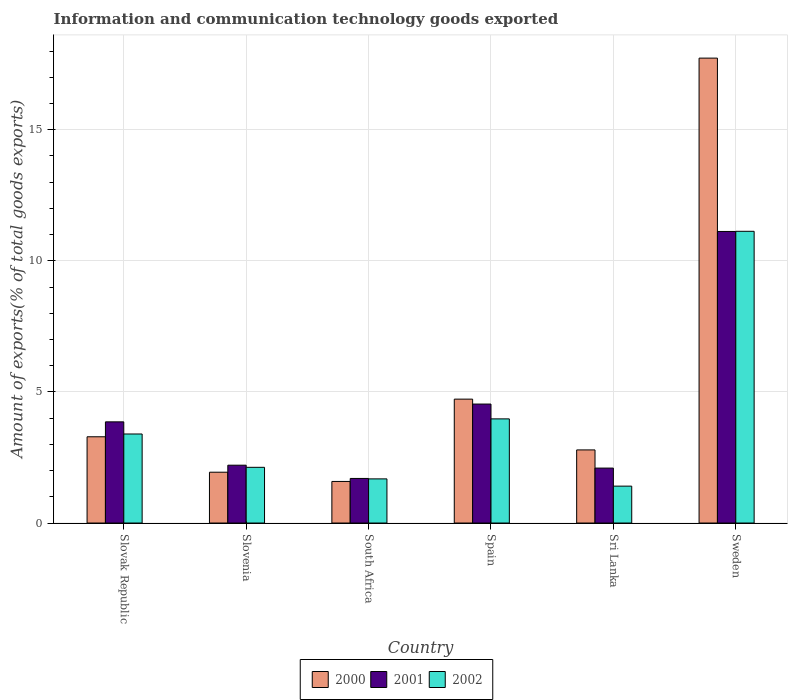How many different coloured bars are there?
Provide a short and direct response. 3. How many groups of bars are there?
Offer a terse response. 6. How many bars are there on the 2nd tick from the left?
Make the answer very short. 3. How many bars are there on the 5th tick from the right?
Keep it short and to the point. 3. What is the label of the 2nd group of bars from the left?
Offer a terse response. Slovenia. In how many cases, is the number of bars for a given country not equal to the number of legend labels?
Your answer should be very brief. 0. What is the amount of goods exported in 2001 in Spain?
Provide a short and direct response. 4.54. Across all countries, what is the maximum amount of goods exported in 2001?
Keep it short and to the point. 11.12. Across all countries, what is the minimum amount of goods exported in 2000?
Your answer should be very brief. 1.59. In which country was the amount of goods exported in 2000 minimum?
Provide a succinct answer. South Africa. What is the total amount of goods exported in 2002 in the graph?
Give a very brief answer. 23.71. What is the difference between the amount of goods exported in 2001 in South Africa and that in Sweden?
Offer a terse response. -9.42. What is the difference between the amount of goods exported in 2000 in Sri Lanka and the amount of goods exported in 2002 in Sweden?
Keep it short and to the point. -8.34. What is the average amount of goods exported in 2002 per country?
Your response must be concise. 3.95. What is the difference between the amount of goods exported of/in 2002 and amount of goods exported of/in 2001 in Slovak Republic?
Give a very brief answer. -0.46. What is the ratio of the amount of goods exported in 2000 in South Africa to that in Sri Lanka?
Ensure brevity in your answer.  0.57. Is the difference between the amount of goods exported in 2002 in Spain and Sweden greater than the difference between the amount of goods exported in 2001 in Spain and Sweden?
Ensure brevity in your answer.  No. What is the difference between the highest and the second highest amount of goods exported in 2000?
Your answer should be compact. 14.44. What is the difference between the highest and the lowest amount of goods exported in 2002?
Give a very brief answer. 9.72. In how many countries, is the amount of goods exported in 2001 greater than the average amount of goods exported in 2001 taken over all countries?
Offer a very short reply. 2. Is it the case that in every country, the sum of the amount of goods exported in 2000 and amount of goods exported in 2001 is greater than the amount of goods exported in 2002?
Make the answer very short. Yes. How many legend labels are there?
Give a very brief answer. 3. What is the title of the graph?
Your response must be concise. Information and communication technology goods exported. What is the label or title of the X-axis?
Provide a succinct answer. Country. What is the label or title of the Y-axis?
Offer a very short reply. Amount of exports(% of total goods exports). What is the Amount of exports(% of total goods exports) in 2000 in Slovak Republic?
Provide a succinct answer. 3.29. What is the Amount of exports(% of total goods exports) of 2001 in Slovak Republic?
Make the answer very short. 3.86. What is the Amount of exports(% of total goods exports) of 2002 in Slovak Republic?
Provide a short and direct response. 3.4. What is the Amount of exports(% of total goods exports) in 2000 in Slovenia?
Your answer should be compact. 1.94. What is the Amount of exports(% of total goods exports) of 2001 in Slovenia?
Your answer should be very brief. 2.21. What is the Amount of exports(% of total goods exports) of 2002 in Slovenia?
Ensure brevity in your answer.  2.12. What is the Amount of exports(% of total goods exports) in 2000 in South Africa?
Keep it short and to the point. 1.59. What is the Amount of exports(% of total goods exports) of 2001 in South Africa?
Offer a terse response. 1.7. What is the Amount of exports(% of total goods exports) in 2002 in South Africa?
Offer a terse response. 1.68. What is the Amount of exports(% of total goods exports) in 2000 in Spain?
Provide a succinct answer. 4.72. What is the Amount of exports(% of total goods exports) in 2001 in Spain?
Give a very brief answer. 4.54. What is the Amount of exports(% of total goods exports) in 2002 in Spain?
Your answer should be compact. 3.97. What is the Amount of exports(% of total goods exports) in 2000 in Sri Lanka?
Your response must be concise. 2.79. What is the Amount of exports(% of total goods exports) of 2001 in Sri Lanka?
Provide a short and direct response. 2.1. What is the Amount of exports(% of total goods exports) of 2002 in Sri Lanka?
Ensure brevity in your answer.  1.41. What is the Amount of exports(% of total goods exports) in 2000 in Sweden?
Your answer should be compact. 17.73. What is the Amount of exports(% of total goods exports) of 2001 in Sweden?
Provide a short and direct response. 11.12. What is the Amount of exports(% of total goods exports) of 2002 in Sweden?
Provide a succinct answer. 11.13. Across all countries, what is the maximum Amount of exports(% of total goods exports) in 2000?
Provide a succinct answer. 17.73. Across all countries, what is the maximum Amount of exports(% of total goods exports) of 2001?
Provide a succinct answer. 11.12. Across all countries, what is the maximum Amount of exports(% of total goods exports) of 2002?
Provide a succinct answer. 11.13. Across all countries, what is the minimum Amount of exports(% of total goods exports) of 2000?
Your response must be concise. 1.59. Across all countries, what is the minimum Amount of exports(% of total goods exports) of 2001?
Ensure brevity in your answer.  1.7. Across all countries, what is the minimum Amount of exports(% of total goods exports) of 2002?
Make the answer very short. 1.41. What is the total Amount of exports(% of total goods exports) of 2000 in the graph?
Your answer should be compact. 32.06. What is the total Amount of exports(% of total goods exports) in 2001 in the graph?
Offer a very short reply. 25.52. What is the total Amount of exports(% of total goods exports) in 2002 in the graph?
Your answer should be very brief. 23.71. What is the difference between the Amount of exports(% of total goods exports) of 2000 in Slovak Republic and that in Slovenia?
Offer a terse response. 1.35. What is the difference between the Amount of exports(% of total goods exports) of 2001 in Slovak Republic and that in Slovenia?
Give a very brief answer. 1.65. What is the difference between the Amount of exports(% of total goods exports) of 2002 in Slovak Republic and that in Slovenia?
Your answer should be compact. 1.27. What is the difference between the Amount of exports(% of total goods exports) in 2000 in Slovak Republic and that in South Africa?
Give a very brief answer. 1.7. What is the difference between the Amount of exports(% of total goods exports) of 2001 in Slovak Republic and that in South Africa?
Offer a very short reply. 2.16. What is the difference between the Amount of exports(% of total goods exports) of 2002 in Slovak Republic and that in South Africa?
Give a very brief answer. 1.71. What is the difference between the Amount of exports(% of total goods exports) in 2000 in Slovak Republic and that in Spain?
Your answer should be very brief. -1.44. What is the difference between the Amount of exports(% of total goods exports) of 2001 in Slovak Republic and that in Spain?
Offer a very short reply. -0.68. What is the difference between the Amount of exports(% of total goods exports) of 2002 in Slovak Republic and that in Spain?
Your response must be concise. -0.58. What is the difference between the Amount of exports(% of total goods exports) in 2000 in Slovak Republic and that in Sri Lanka?
Your response must be concise. 0.5. What is the difference between the Amount of exports(% of total goods exports) in 2001 in Slovak Republic and that in Sri Lanka?
Offer a very short reply. 1.76. What is the difference between the Amount of exports(% of total goods exports) in 2002 in Slovak Republic and that in Sri Lanka?
Keep it short and to the point. 1.99. What is the difference between the Amount of exports(% of total goods exports) of 2000 in Slovak Republic and that in Sweden?
Ensure brevity in your answer.  -14.44. What is the difference between the Amount of exports(% of total goods exports) of 2001 in Slovak Republic and that in Sweden?
Make the answer very short. -7.26. What is the difference between the Amount of exports(% of total goods exports) of 2002 in Slovak Republic and that in Sweden?
Offer a very short reply. -7.73. What is the difference between the Amount of exports(% of total goods exports) in 2000 in Slovenia and that in South Africa?
Your answer should be compact. 0.35. What is the difference between the Amount of exports(% of total goods exports) in 2001 in Slovenia and that in South Africa?
Your response must be concise. 0.51. What is the difference between the Amount of exports(% of total goods exports) in 2002 in Slovenia and that in South Africa?
Make the answer very short. 0.44. What is the difference between the Amount of exports(% of total goods exports) in 2000 in Slovenia and that in Spain?
Give a very brief answer. -2.79. What is the difference between the Amount of exports(% of total goods exports) of 2001 in Slovenia and that in Spain?
Make the answer very short. -2.33. What is the difference between the Amount of exports(% of total goods exports) of 2002 in Slovenia and that in Spain?
Offer a terse response. -1.85. What is the difference between the Amount of exports(% of total goods exports) in 2000 in Slovenia and that in Sri Lanka?
Offer a terse response. -0.85. What is the difference between the Amount of exports(% of total goods exports) of 2001 in Slovenia and that in Sri Lanka?
Make the answer very short. 0.11. What is the difference between the Amount of exports(% of total goods exports) of 2002 in Slovenia and that in Sri Lanka?
Make the answer very short. 0.72. What is the difference between the Amount of exports(% of total goods exports) of 2000 in Slovenia and that in Sweden?
Give a very brief answer. -15.79. What is the difference between the Amount of exports(% of total goods exports) in 2001 in Slovenia and that in Sweden?
Offer a very short reply. -8.91. What is the difference between the Amount of exports(% of total goods exports) in 2002 in Slovenia and that in Sweden?
Keep it short and to the point. -9. What is the difference between the Amount of exports(% of total goods exports) of 2000 in South Africa and that in Spain?
Offer a terse response. -3.14. What is the difference between the Amount of exports(% of total goods exports) in 2001 in South Africa and that in Spain?
Make the answer very short. -2.84. What is the difference between the Amount of exports(% of total goods exports) in 2002 in South Africa and that in Spain?
Your response must be concise. -2.29. What is the difference between the Amount of exports(% of total goods exports) of 2000 in South Africa and that in Sri Lanka?
Offer a terse response. -1.2. What is the difference between the Amount of exports(% of total goods exports) in 2001 in South Africa and that in Sri Lanka?
Your answer should be very brief. -0.4. What is the difference between the Amount of exports(% of total goods exports) of 2002 in South Africa and that in Sri Lanka?
Offer a terse response. 0.28. What is the difference between the Amount of exports(% of total goods exports) in 2000 in South Africa and that in Sweden?
Make the answer very short. -16.14. What is the difference between the Amount of exports(% of total goods exports) of 2001 in South Africa and that in Sweden?
Offer a very short reply. -9.42. What is the difference between the Amount of exports(% of total goods exports) in 2002 in South Africa and that in Sweden?
Offer a very short reply. -9.44. What is the difference between the Amount of exports(% of total goods exports) of 2000 in Spain and that in Sri Lanka?
Offer a terse response. 1.94. What is the difference between the Amount of exports(% of total goods exports) of 2001 in Spain and that in Sri Lanka?
Provide a short and direct response. 2.44. What is the difference between the Amount of exports(% of total goods exports) in 2002 in Spain and that in Sri Lanka?
Your answer should be very brief. 2.56. What is the difference between the Amount of exports(% of total goods exports) in 2000 in Spain and that in Sweden?
Give a very brief answer. -13. What is the difference between the Amount of exports(% of total goods exports) in 2001 in Spain and that in Sweden?
Offer a terse response. -6.58. What is the difference between the Amount of exports(% of total goods exports) of 2002 in Spain and that in Sweden?
Provide a short and direct response. -7.15. What is the difference between the Amount of exports(% of total goods exports) of 2000 in Sri Lanka and that in Sweden?
Your answer should be very brief. -14.94. What is the difference between the Amount of exports(% of total goods exports) of 2001 in Sri Lanka and that in Sweden?
Your response must be concise. -9.02. What is the difference between the Amount of exports(% of total goods exports) of 2002 in Sri Lanka and that in Sweden?
Provide a short and direct response. -9.72. What is the difference between the Amount of exports(% of total goods exports) in 2000 in Slovak Republic and the Amount of exports(% of total goods exports) in 2001 in Slovenia?
Your response must be concise. 1.08. What is the difference between the Amount of exports(% of total goods exports) of 2000 in Slovak Republic and the Amount of exports(% of total goods exports) of 2002 in Slovenia?
Provide a succinct answer. 1.16. What is the difference between the Amount of exports(% of total goods exports) of 2001 in Slovak Republic and the Amount of exports(% of total goods exports) of 2002 in Slovenia?
Provide a short and direct response. 1.73. What is the difference between the Amount of exports(% of total goods exports) of 2000 in Slovak Republic and the Amount of exports(% of total goods exports) of 2001 in South Africa?
Keep it short and to the point. 1.59. What is the difference between the Amount of exports(% of total goods exports) of 2000 in Slovak Republic and the Amount of exports(% of total goods exports) of 2002 in South Africa?
Your answer should be compact. 1.61. What is the difference between the Amount of exports(% of total goods exports) of 2001 in Slovak Republic and the Amount of exports(% of total goods exports) of 2002 in South Africa?
Provide a succinct answer. 2.18. What is the difference between the Amount of exports(% of total goods exports) in 2000 in Slovak Republic and the Amount of exports(% of total goods exports) in 2001 in Spain?
Keep it short and to the point. -1.25. What is the difference between the Amount of exports(% of total goods exports) of 2000 in Slovak Republic and the Amount of exports(% of total goods exports) of 2002 in Spain?
Your answer should be compact. -0.68. What is the difference between the Amount of exports(% of total goods exports) in 2001 in Slovak Republic and the Amount of exports(% of total goods exports) in 2002 in Spain?
Offer a very short reply. -0.11. What is the difference between the Amount of exports(% of total goods exports) of 2000 in Slovak Republic and the Amount of exports(% of total goods exports) of 2001 in Sri Lanka?
Your answer should be compact. 1.19. What is the difference between the Amount of exports(% of total goods exports) of 2000 in Slovak Republic and the Amount of exports(% of total goods exports) of 2002 in Sri Lanka?
Offer a very short reply. 1.88. What is the difference between the Amount of exports(% of total goods exports) of 2001 in Slovak Republic and the Amount of exports(% of total goods exports) of 2002 in Sri Lanka?
Ensure brevity in your answer.  2.45. What is the difference between the Amount of exports(% of total goods exports) of 2000 in Slovak Republic and the Amount of exports(% of total goods exports) of 2001 in Sweden?
Give a very brief answer. -7.83. What is the difference between the Amount of exports(% of total goods exports) of 2000 in Slovak Republic and the Amount of exports(% of total goods exports) of 2002 in Sweden?
Your response must be concise. -7.84. What is the difference between the Amount of exports(% of total goods exports) in 2001 in Slovak Republic and the Amount of exports(% of total goods exports) in 2002 in Sweden?
Your answer should be compact. -7.27. What is the difference between the Amount of exports(% of total goods exports) of 2000 in Slovenia and the Amount of exports(% of total goods exports) of 2001 in South Africa?
Offer a very short reply. 0.24. What is the difference between the Amount of exports(% of total goods exports) in 2000 in Slovenia and the Amount of exports(% of total goods exports) in 2002 in South Africa?
Provide a succinct answer. 0.25. What is the difference between the Amount of exports(% of total goods exports) in 2001 in Slovenia and the Amount of exports(% of total goods exports) in 2002 in South Africa?
Ensure brevity in your answer.  0.52. What is the difference between the Amount of exports(% of total goods exports) of 2000 in Slovenia and the Amount of exports(% of total goods exports) of 2001 in Spain?
Give a very brief answer. -2.6. What is the difference between the Amount of exports(% of total goods exports) in 2000 in Slovenia and the Amount of exports(% of total goods exports) in 2002 in Spain?
Your answer should be very brief. -2.03. What is the difference between the Amount of exports(% of total goods exports) in 2001 in Slovenia and the Amount of exports(% of total goods exports) in 2002 in Spain?
Offer a very short reply. -1.77. What is the difference between the Amount of exports(% of total goods exports) in 2000 in Slovenia and the Amount of exports(% of total goods exports) in 2001 in Sri Lanka?
Keep it short and to the point. -0.16. What is the difference between the Amount of exports(% of total goods exports) of 2000 in Slovenia and the Amount of exports(% of total goods exports) of 2002 in Sri Lanka?
Make the answer very short. 0.53. What is the difference between the Amount of exports(% of total goods exports) in 2001 in Slovenia and the Amount of exports(% of total goods exports) in 2002 in Sri Lanka?
Make the answer very short. 0.8. What is the difference between the Amount of exports(% of total goods exports) in 2000 in Slovenia and the Amount of exports(% of total goods exports) in 2001 in Sweden?
Your answer should be very brief. -9.18. What is the difference between the Amount of exports(% of total goods exports) in 2000 in Slovenia and the Amount of exports(% of total goods exports) in 2002 in Sweden?
Make the answer very short. -9.19. What is the difference between the Amount of exports(% of total goods exports) of 2001 in Slovenia and the Amount of exports(% of total goods exports) of 2002 in Sweden?
Your answer should be very brief. -8.92. What is the difference between the Amount of exports(% of total goods exports) in 2000 in South Africa and the Amount of exports(% of total goods exports) in 2001 in Spain?
Provide a succinct answer. -2.95. What is the difference between the Amount of exports(% of total goods exports) of 2000 in South Africa and the Amount of exports(% of total goods exports) of 2002 in Spain?
Your answer should be compact. -2.39. What is the difference between the Amount of exports(% of total goods exports) of 2001 in South Africa and the Amount of exports(% of total goods exports) of 2002 in Spain?
Ensure brevity in your answer.  -2.27. What is the difference between the Amount of exports(% of total goods exports) in 2000 in South Africa and the Amount of exports(% of total goods exports) in 2001 in Sri Lanka?
Your response must be concise. -0.51. What is the difference between the Amount of exports(% of total goods exports) of 2000 in South Africa and the Amount of exports(% of total goods exports) of 2002 in Sri Lanka?
Your answer should be compact. 0.18. What is the difference between the Amount of exports(% of total goods exports) of 2001 in South Africa and the Amount of exports(% of total goods exports) of 2002 in Sri Lanka?
Keep it short and to the point. 0.29. What is the difference between the Amount of exports(% of total goods exports) of 2000 in South Africa and the Amount of exports(% of total goods exports) of 2001 in Sweden?
Your answer should be very brief. -9.53. What is the difference between the Amount of exports(% of total goods exports) of 2000 in South Africa and the Amount of exports(% of total goods exports) of 2002 in Sweden?
Your answer should be very brief. -9.54. What is the difference between the Amount of exports(% of total goods exports) of 2001 in South Africa and the Amount of exports(% of total goods exports) of 2002 in Sweden?
Your answer should be compact. -9.42. What is the difference between the Amount of exports(% of total goods exports) of 2000 in Spain and the Amount of exports(% of total goods exports) of 2001 in Sri Lanka?
Provide a short and direct response. 2.63. What is the difference between the Amount of exports(% of total goods exports) in 2000 in Spain and the Amount of exports(% of total goods exports) in 2002 in Sri Lanka?
Offer a very short reply. 3.32. What is the difference between the Amount of exports(% of total goods exports) of 2001 in Spain and the Amount of exports(% of total goods exports) of 2002 in Sri Lanka?
Provide a short and direct response. 3.13. What is the difference between the Amount of exports(% of total goods exports) in 2000 in Spain and the Amount of exports(% of total goods exports) in 2001 in Sweden?
Your answer should be very brief. -6.39. What is the difference between the Amount of exports(% of total goods exports) of 2000 in Spain and the Amount of exports(% of total goods exports) of 2002 in Sweden?
Keep it short and to the point. -6.4. What is the difference between the Amount of exports(% of total goods exports) in 2001 in Spain and the Amount of exports(% of total goods exports) in 2002 in Sweden?
Provide a short and direct response. -6.59. What is the difference between the Amount of exports(% of total goods exports) of 2000 in Sri Lanka and the Amount of exports(% of total goods exports) of 2001 in Sweden?
Offer a very short reply. -8.33. What is the difference between the Amount of exports(% of total goods exports) of 2000 in Sri Lanka and the Amount of exports(% of total goods exports) of 2002 in Sweden?
Provide a succinct answer. -8.34. What is the difference between the Amount of exports(% of total goods exports) of 2001 in Sri Lanka and the Amount of exports(% of total goods exports) of 2002 in Sweden?
Offer a very short reply. -9.03. What is the average Amount of exports(% of total goods exports) in 2000 per country?
Ensure brevity in your answer.  5.34. What is the average Amount of exports(% of total goods exports) of 2001 per country?
Your response must be concise. 4.25. What is the average Amount of exports(% of total goods exports) in 2002 per country?
Give a very brief answer. 3.95. What is the difference between the Amount of exports(% of total goods exports) of 2000 and Amount of exports(% of total goods exports) of 2001 in Slovak Republic?
Give a very brief answer. -0.57. What is the difference between the Amount of exports(% of total goods exports) in 2000 and Amount of exports(% of total goods exports) in 2002 in Slovak Republic?
Your response must be concise. -0.11. What is the difference between the Amount of exports(% of total goods exports) of 2001 and Amount of exports(% of total goods exports) of 2002 in Slovak Republic?
Ensure brevity in your answer.  0.46. What is the difference between the Amount of exports(% of total goods exports) in 2000 and Amount of exports(% of total goods exports) in 2001 in Slovenia?
Your response must be concise. -0.27. What is the difference between the Amount of exports(% of total goods exports) of 2000 and Amount of exports(% of total goods exports) of 2002 in Slovenia?
Ensure brevity in your answer.  -0.19. What is the difference between the Amount of exports(% of total goods exports) of 2001 and Amount of exports(% of total goods exports) of 2002 in Slovenia?
Provide a short and direct response. 0.08. What is the difference between the Amount of exports(% of total goods exports) of 2000 and Amount of exports(% of total goods exports) of 2001 in South Africa?
Your answer should be very brief. -0.11. What is the difference between the Amount of exports(% of total goods exports) in 2000 and Amount of exports(% of total goods exports) in 2002 in South Africa?
Make the answer very short. -0.1. What is the difference between the Amount of exports(% of total goods exports) in 2001 and Amount of exports(% of total goods exports) in 2002 in South Africa?
Your response must be concise. 0.02. What is the difference between the Amount of exports(% of total goods exports) of 2000 and Amount of exports(% of total goods exports) of 2001 in Spain?
Give a very brief answer. 0.19. What is the difference between the Amount of exports(% of total goods exports) of 2000 and Amount of exports(% of total goods exports) of 2002 in Spain?
Offer a very short reply. 0.75. What is the difference between the Amount of exports(% of total goods exports) in 2001 and Amount of exports(% of total goods exports) in 2002 in Spain?
Provide a short and direct response. 0.57. What is the difference between the Amount of exports(% of total goods exports) in 2000 and Amount of exports(% of total goods exports) in 2001 in Sri Lanka?
Your answer should be very brief. 0.69. What is the difference between the Amount of exports(% of total goods exports) of 2000 and Amount of exports(% of total goods exports) of 2002 in Sri Lanka?
Provide a succinct answer. 1.38. What is the difference between the Amount of exports(% of total goods exports) in 2001 and Amount of exports(% of total goods exports) in 2002 in Sri Lanka?
Keep it short and to the point. 0.69. What is the difference between the Amount of exports(% of total goods exports) in 2000 and Amount of exports(% of total goods exports) in 2001 in Sweden?
Give a very brief answer. 6.61. What is the difference between the Amount of exports(% of total goods exports) in 2000 and Amount of exports(% of total goods exports) in 2002 in Sweden?
Make the answer very short. 6.6. What is the difference between the Amount of exports(% of total goods exports) of 2001 and Amount of exports(% of total goods exports) of 2002 in Sweden?
Offer a terse response. -0.01. What is the ratio of the Amount of exports(% of total goods exports) of 2000 in Slovak Republic to that in Slovenia?
Make the answer very short. 1.7. What is the ratio of the Amount of exports(% of total goods exports) in 2001 in Slovak Republic to that in Slovenia?
Offer a very short reply. 1.75. What is the ratio of the Amount of exports(% of total goods exports) in 2002 in Slovak Republic to that in Slovenia?
Provide a short and direct response. 1.6. What is the ratio of the Amount of exports(% of total goods exports) in 2000 in Slovak Republic to that in South Africa?
Your response must be concise. 2.07. What is the ratio of the Amount of exports(% of total goods exports) in 2001 in Slovak Republic to that in South Africa?
Provide a succinct answer. 2.27. What is the ratio of the Amount of exports(% of total goods exports) in 2002 in Slovak Republic to that in South Africa?
Provide a short and direct response. 2.02. What is the ratio of the Amount of exports(% of total goods exports) in 2000 in Slovak Republic to that in Spain?
Your answer should be compact. 0.7. What is the ratio of the Amount of exports(% of total goods exports) in 2001 in Slovak Republic to that in Spain?
Your answer should be compact. 0.85. What is the ratio of the Amount of exports(% of total goods exports) in 2002 in Slovak Republic to that in Spain?
Your response must be concise. 0.85. What is the ratio of the Amount of exports(% of total goods exports) in 2000 in Slovak Republic to that in Sri Lanka?
Provide a succinct answer. 1.18. What is the ratio of the Amount of exports(% of total goods exports) of 2001 in Slovak Republic to that in Sri Lanka?
Ensure brevity in your answer.  1.84. What is the ratio of the Amount of exports(% of total goods exports) in 2002 in Slovak Republic to that in Sri Lanka?
Offer a very short reply. 2.41. What is the ratio of the Amount of exports(% of total goods exports) of 2000 in Slovak Republic to that in Sweden?
Your answer should be very brief. 0.19. What is the ratio of the Amount of exports(% of total goods exports) in 2001 in Slovak Republic to that in Sweden?
Make the answer very short. 0.35. What is the ratio of the Amount of exports(% of total goods exports) of 2002 in Slovak Republic to that in Sweden?
Keep it short and to the point. 0.31. What is the ratio of the Amount of exports(% of total goods exports) in 2000 in Slovenia to that in South Africa?
Your response must be concise. 1.22. What is the ratio of the Amount of exports(% of total goods exports) of 2001 in Slovenia to that in South Africa?
Keep it short and to the point. 1.3. What is the ratio of the Amount of exports(% of total goods exports) in 2002 in Slovenia to that in South Africa?
Your answer should be very brief. 1.26. What is the ratio of the Amount of exports(% of total goods exports) in 2000 in Slovenia to that in Spain?
Offer a very short reply. 0.41. What is the ratio of the Amount of exports(% of total goods exports) in 2001 in Slovenia to that in Spain?
Provide a succinct answer. 0.49. What is the ratio of the Amount of exports(% of total goods exports) in 2002 in Slovenia to that in Spain?
Give a very brief answer. 0.53. What is the ratio of the Amount of exports(% of total goods exports) in 2000 in Slovenia to that in Sri Lanka?
Your response must be concise. 0.7. What is the ratio of the Amount of exports(% of total goods exports) of 2001 in Slovenia to that in Sri Lanka?
Your response must be concise. 1.05. What is the ratio of the Amount of exports(% of total goods exports) in 2002 in Slovenia to that in Sri Lanka?
Your answer should be very brief. 1.51. What is the ratio of the Amount of exports(% of total goods exports) in 2000 in Slovenia to that in Sweden?
Make the answer very short. 0.11. What is the ratio of the Amount of exports(% of total goods exports) of 2001 in Slovenia to that in Sweden?
Give a very brief answer. 0.2. What is the ratio of the Amount of exports(% of total goods exports) of 2002 in Slovenia to that in Sweden?
Offer a terse response. 0.19. What is the ratio of the Amount of exports(% of total goods exports) of 2000 in South Africa to that in Spain?
Give a very brief answer. 0.34. What is the ratio of the Amount of exports(% of total goods exports) of 2001 in South Africa to that in Spain?
Make the answer very short. 0.37. What is the ratio of the Amount of exports(% of total goods exports) of 2002 in South Africa to that in Spain?
Provide a succinct answer. 0.42. What is the ratio of the Amount of exports(% of total goods exports) in 2000 in South Africa to that in Sri Lanka?
Offer a very short reply. 0.57. What is the ratio of the Amount of exports(% of total goods exports) of 2001 in South Africa to that in Sri Lanka?
Make the answer very short. 0.81. What is the ratio of the Amount of exports(% of total goods exports) in 2002 in South Africa to that in Sri Lanka?
Give a very brief answer. 1.2. What is the ratio of the Amount of exports(% of total goods exports) of 2000 in South Africa to that in Sweden?
Keep it short and to the point. 0.09. What is the ratio of the Amount of exports(% of total goods exports) in 2001 in South Africa to that in Sweden?
Offer a terse response. 0.15. What is the ratio of the Amount of exports(% of total goods exports) in 2002 in South Africa to that in Sweden?
Keep it short and to the point. 0.15. What is the ratio of the Amount of exports(% of total goods exports) in 2000 in Spain to that in Sri Lanka?
Make the answer very short. 1.69. What is the ratio of the Amount of exports(% of total goods exports) of 2001 in Spain to that in Sri Lanka?
Make the answer very short. 2.17. What is the ratio of the Amount of exports(% of total goods exports) in 2002 in Spain to that in Sri Lanka?
Make the answer very short. 2.82. What is the ratio of the Amount of exports(% of total goods exports) of 2000 in Spain to that in Sweden?
Ensure brevity in your answer.  0.27. What is the ratio of the Amount of exports(% of total goods exports) in 2001 in Spain to that in Sweden?
Your response must be concise. 0.41. What is the ratio of the Amount of exports(% of total goods exports) of 2002 in Spain to that in Sweden?
Provide a short and direct response. 0.36. What is the ratio of the Amount of exports(% of total goods exports) in 2000 in Sri Lanka to that in Sweden?
Offer a very short reply. 0.16. What is the ratio of the Amount of exports(% of total goods exports) in 2001 in Sri Lanka to that in Sweden?
Offer a terse response. 0.19. What is the ratio of the Amount of exports(% of total goods exports) in 2002 in Sri Lanka to that in Sweden?
Your answer should be compact. 0.13. What is the difference between the highest and the second highest Amount of exports(% of total goods exports) in 2000?
Offer a terse response. 13. What is the difference between the highest and the second highest Amount of exports(% of total goods exports) of 2001?
Provide a succinct answer. 6.58. What is the difference between the highest and the second highest Amount of exports(% of total goods exports) in 2002?
Offer a very short reply. 7.15. What is the difference between the highest and the lowest Amount of exports(% of total goods exports) in 2000?
Your response must be concise. 16.14. What is the difference between the highest and the lowest Amount of exports(% of total goods exports) of 2001?
Give a very brief answer. 9.42. What is the difference between the highest and the lowest Amount of exports(% of total goods exports) in 2002?
Offer a terse response. 9.72. 